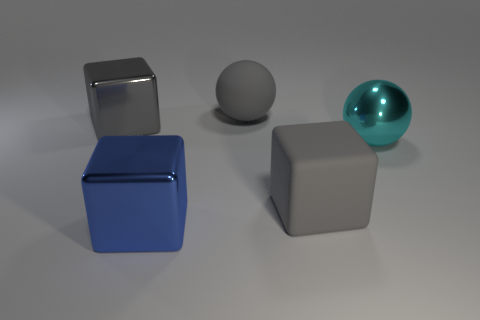Are there any big gray balls that have the same material as the big blue block?
Your answer should be very brief. No. The large rubber cube is what color?
Provide a short and direct response. Gray. What shape is the matte object that is the same color as the big matte sphere?
Provide a short and direct response. Cube. What is the color of the metallic sphere that is the same size as the blue thing?
Offer a very short reply. Cyan. What number of matte things are spheres or big cyan objects?
Your answer should be very brief. 1. What number of big gray things are in front of the gray rubber sphere and to the right of the big blue object?
Your response must be concise. 1. What number of other things are there of the same size as the matte cube?
Give a very brief answer. 4. There is a metal block that is behind the cyan object; does it have the same size as the gray rubber object behind the matte block?
Provide a succinct answer. Yes. How many things are big spheres or big gray cubes that are in front of the big gray metallic object?
Make the answer very short. 3. What is the size of the matte object behind the big matte cube?
Give a very brief answer. Large. 